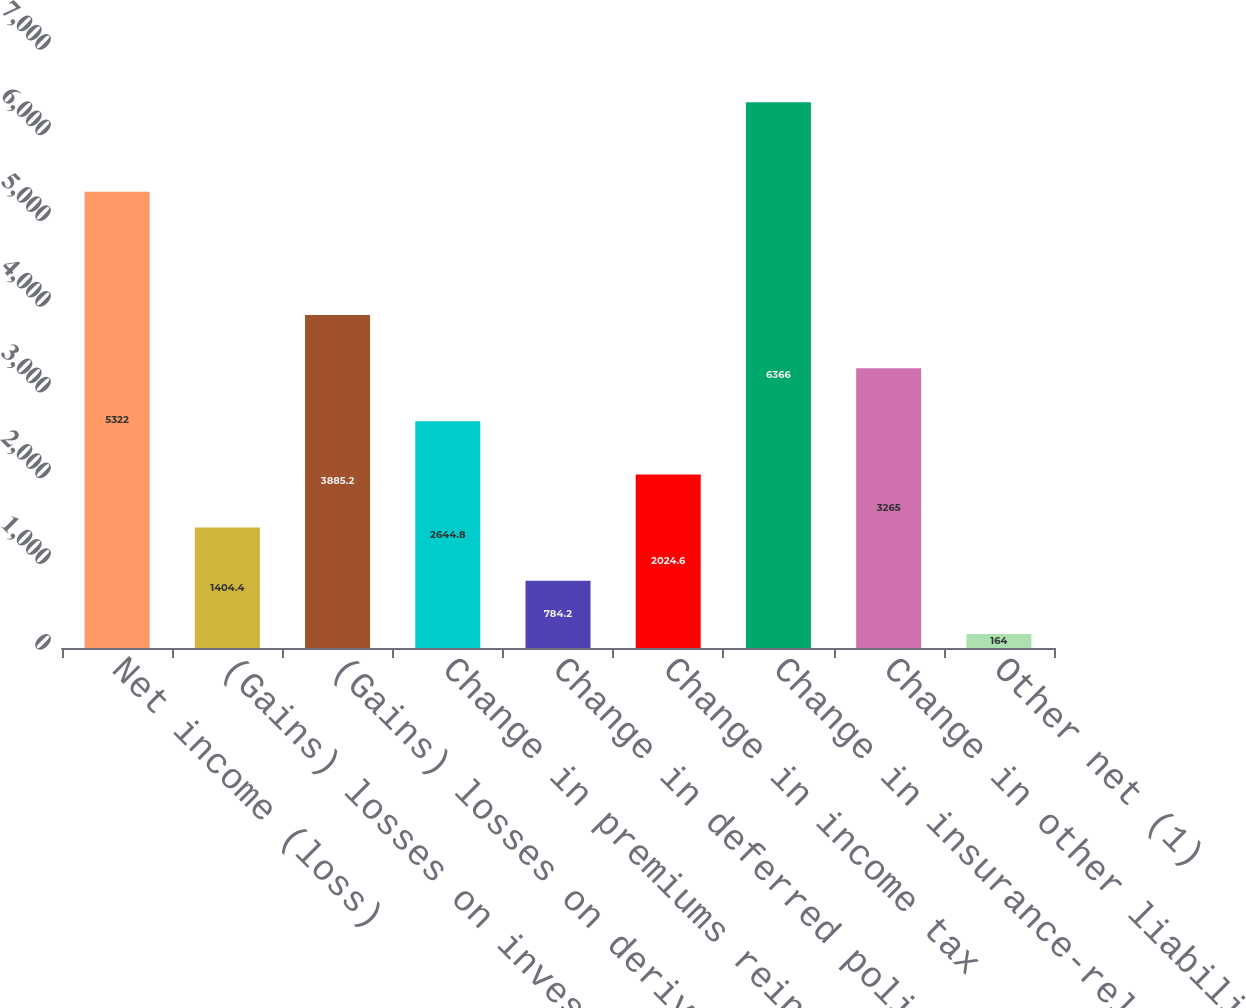Convert chart. <chart><loc_0><loc_0><loc_500><loc_500><bar_chart><fcel>Net income (loss)<fcel>(Gains) losses on investments<fcel>(Gains) losses on derivatives<fcel>Change in premiums reinsurance<fcel>Change in deferred policy<fcel>Change in income tax<fcel>Change in insurance-related<fcel>Change in other liabilities<fcel>Other net (1)<nl><fcel>5322<fcel>1404.4<fcel>3885.2<fcel>2644.8<fcel>784.2<fcel>2024.6<fcel>6366<fcel>3265<fcel>164<nl></chart> 